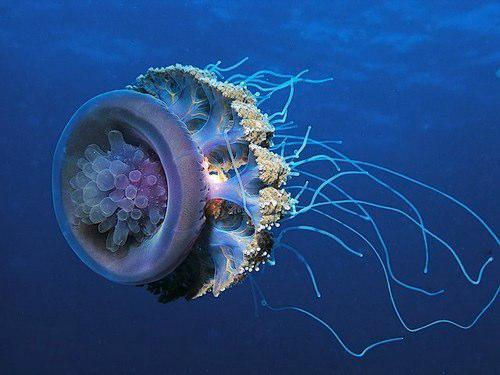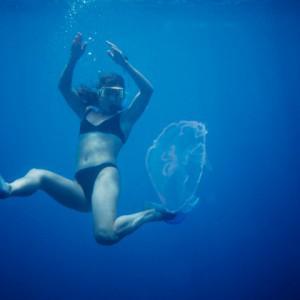The first image is the image on the left, the second image is the image on the right. For the images shown, is this caption "A woman in a swimsuit is in the water near a jellyfish in the right image, and the left image features one jellyfish with tentacles trailing horizontally." true? Answer yes or no. Yes. The first image is the image on the left, the second image is the image on the right. Given the left and right images, does the statement "A woman in a swimsuit swims in the water near at least one jellyfish in the image on the right." hold true? Answer yes or no. Yes. 